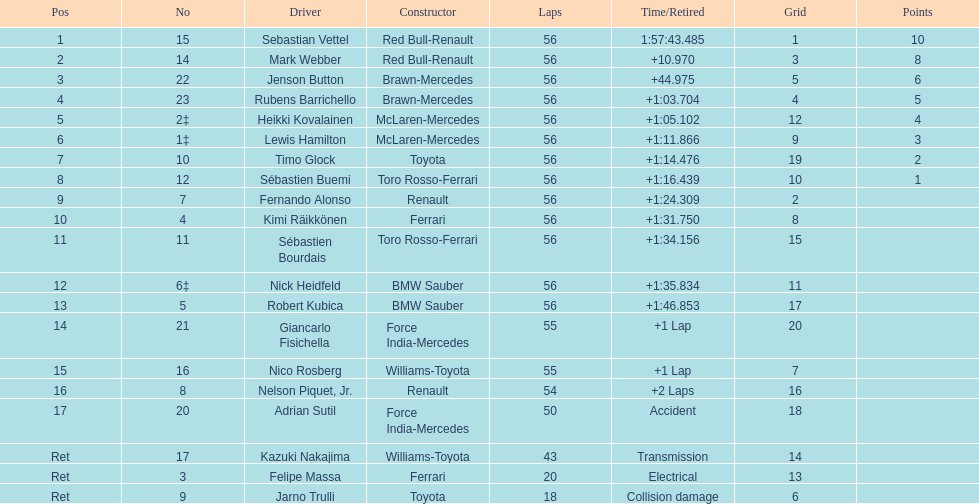What is the name of a driver that ferrari was not a constructor for? Sebastian Vettel. Can you give me this table as a dict? {'header': ['Pos', 'No', 'Driver', 'Constructor', 'Laps', 'Time/Retired', 'Grid', 'Points'], 'rows': [['1', '15', 'Sebastian Vettel', 'Red Bull-Renault', '56', '1:57:43.485', '1', '10'], ['2', '14', 'Mark Webber', 'Red Bull-Renault', '56', '+10.970', '3', '8'], ['3', '22', 'Jenson Button', 'Brawn-Mercedes', '56', '+44.975', '5', '6'], ['4', '23', 'Rubens Barrichello', 'Brawn-Mercedes', '56', '+1:03.704', '4', '5'], ['5', '2‡', 'Heikki Kovalainen', 'McLaren-Mercedes', '56', '+1:05.102', '12', '4'], ['6', '1‡', 'Lewis Hamilton', 'McLaren-Mercedes', '56', '+1:11.866', '9', '3'], ['7', '10', 'Timo Glock', 'Toyota', '56', '+1:14.476', '19', '2'], ['8', '12', 'Sébastien Buemi', 'Toro Rosso-Ferrari', '56', '+1:16.439', '10', '1'], ['9', '7', 'Fernando Alonso', 'Renault', '56', '+1:24.309', '2', ''], ['10', '4', 'Kimi Räikkönen', 'Ferrari', '56', '+1:31.750', '8', ''], ['11', '11', 'Sébastien Bourdais', 'Toro Rosso-Ferrari', '56', '+1:34.156', '15', ''], ['12', '6‡', 'Nick Heidfeld', 'BMW Sauber', '56', '+1:35.834', '11', ''], ['13', '5', 'Robert Kubica', 'BMW Sauber', '56', '+1:46.853', '17', ''], ['14', '21', 'Giancarlo Fisichella', 'Force India-Mercedes', '55', '+1 Lap', '20', ''], ['15', '16', 'Nico Rosberg', 'Williams-Toyota', '55', '+1 Lap', '7', ''], ['16', '8', 'Nelson Piquet, Jr.', 'Renault', '54', '+2 Laps', '16', ''], ['17', '20', 'Adrian Sutil', 'Force India-Mercedes', '50', 'Accident', '18', ''], ['Ret', '17', 'Kazuki Nakajima', 'Williams-Toyota', '43', 'Transmission', '14', ''], ['Ret', '3', 'Felipe Massa', 'Ferrari', '20', 'Electrical', '13', ''], ['Ret', '9', 'Jarno Trulli', 'Toyota', '18', 'Collision damage', '6', '']]} 